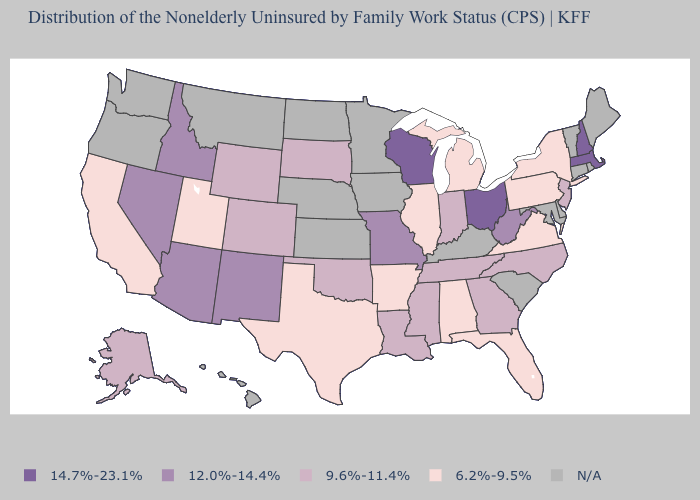Does Pennsylvania have the highest value in the USA?
Keep it brief. No. What is the lowest value in the USA?
Answer briefly. 6.2%-9.5%. What is the highest value in the USA?
Quick response, please. 14.7%-23.1%. What is the value of Oregon?
Concise answer only. N/A. What is the value of Maine?
Answer briefly. N/A. Does the first symbol in the legend represent the smallest category?
Answer briefly. No. Name the states that have a value in the range N/A?
Quick response, please. Connecticut, Delaware, Hawaii, Iowa, Kansas, Kentucky, Maine, Maryland, Minnesota, Montana, Nebraska, North Dakota, Oregon, Rhode Island, South Carolina, Vermont, Washington. Among the states that border Nevada , does Idaho have the lowest value?
Short answer required. No. What is the highest value in states that border Oregon?
Be succinct. 12.0%-14.4%. What is the value of New Mexico?
Quick response, please. 12.0%-14.4%. What is the highest value in the West ?
Short answer required. 12.0%-14.4%. Among the states that border Michigan , which have the lowest value?
Concise answer only. Indiana. Name the states that have a value in the range 14.7%-23.1%?
Quick response, please. Massachusetts, New Hampshire, Ohio, Wisconsin. Name the states that have a value in the range 9.6%-11.4%?
Short answer required. Alaska, Colorado, Georgia, Indiana, Louisiana, Mississippi, New Jersey, North Carolina, Oklahoma, South Dakota, Tennessee, Wyoming. 